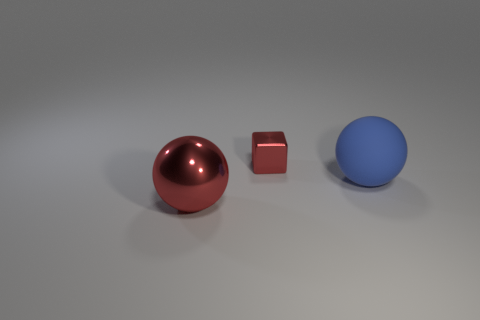There is a block; does it have the same color as the ball that is on the right side of the large red sphere? no 